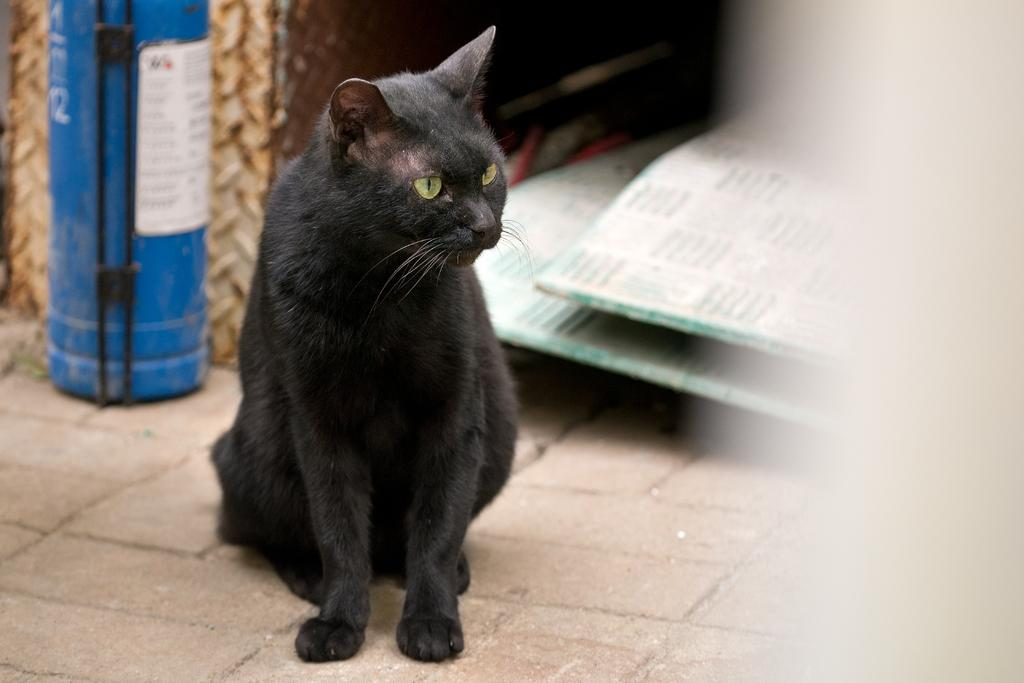What type of animal is present on the surface in the image? There is a cat on the surface in the image. What kind of container can be seen on the surface? There is a metal container on the surface. What other object is present on the surface? There is a box on the surface. What material are the boards on the surface made of? The boards on the surface are made of metal. How many shoes are visible on the surface in the image? There are no shoes present in the image. What type of steam can be seen coming from the cat in the image? There is no steam present in the image, and the cat is not producing any steam. 